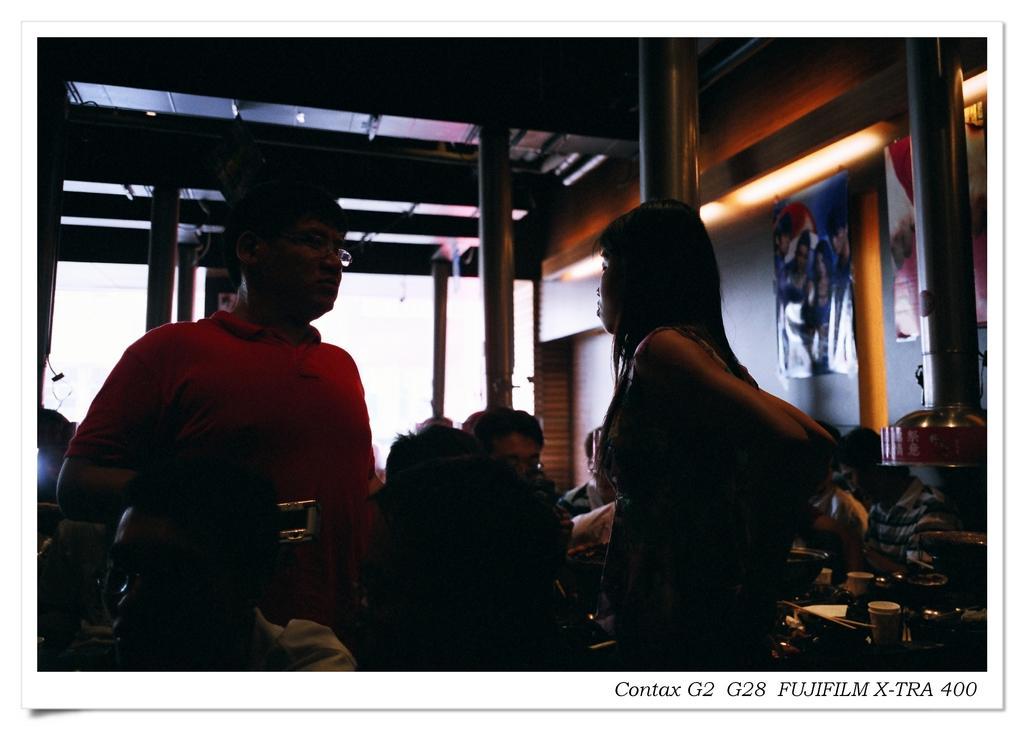Can you describe this image briefly? In this picture we can see a few people sitting on the chair. We can see a man and a woman standing. A text is visible in the bottom right. There are a few posts visible on the wall. We can see a few poles. Some lights are visible on top. 